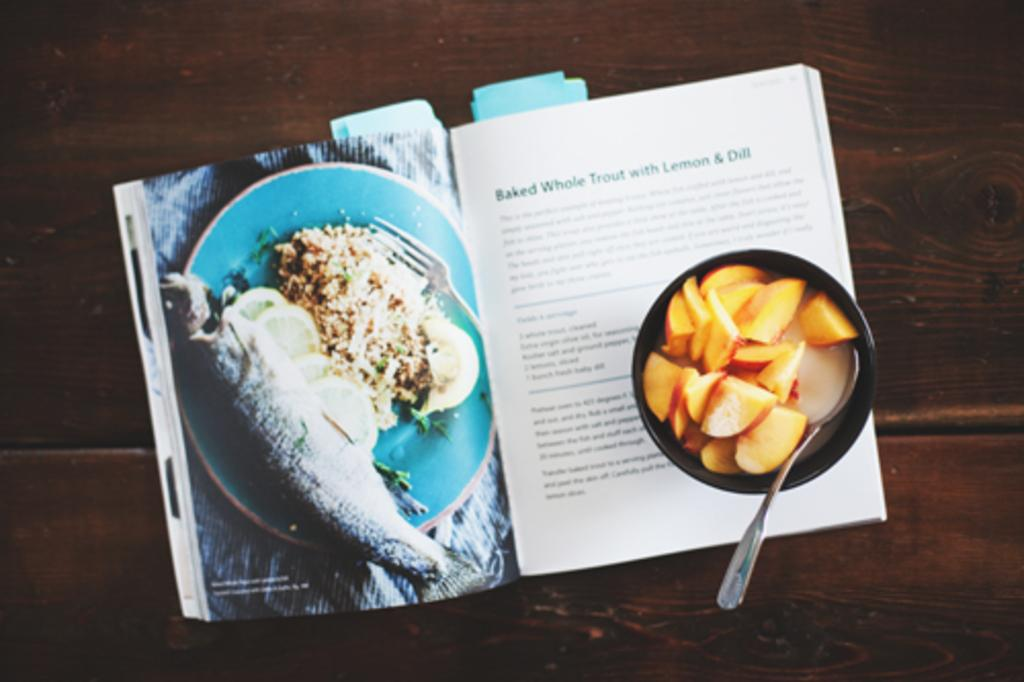<image>
Present a compact description of the photo's key features. A book is open to a recipe for baked whole trout with lemon and dill. 